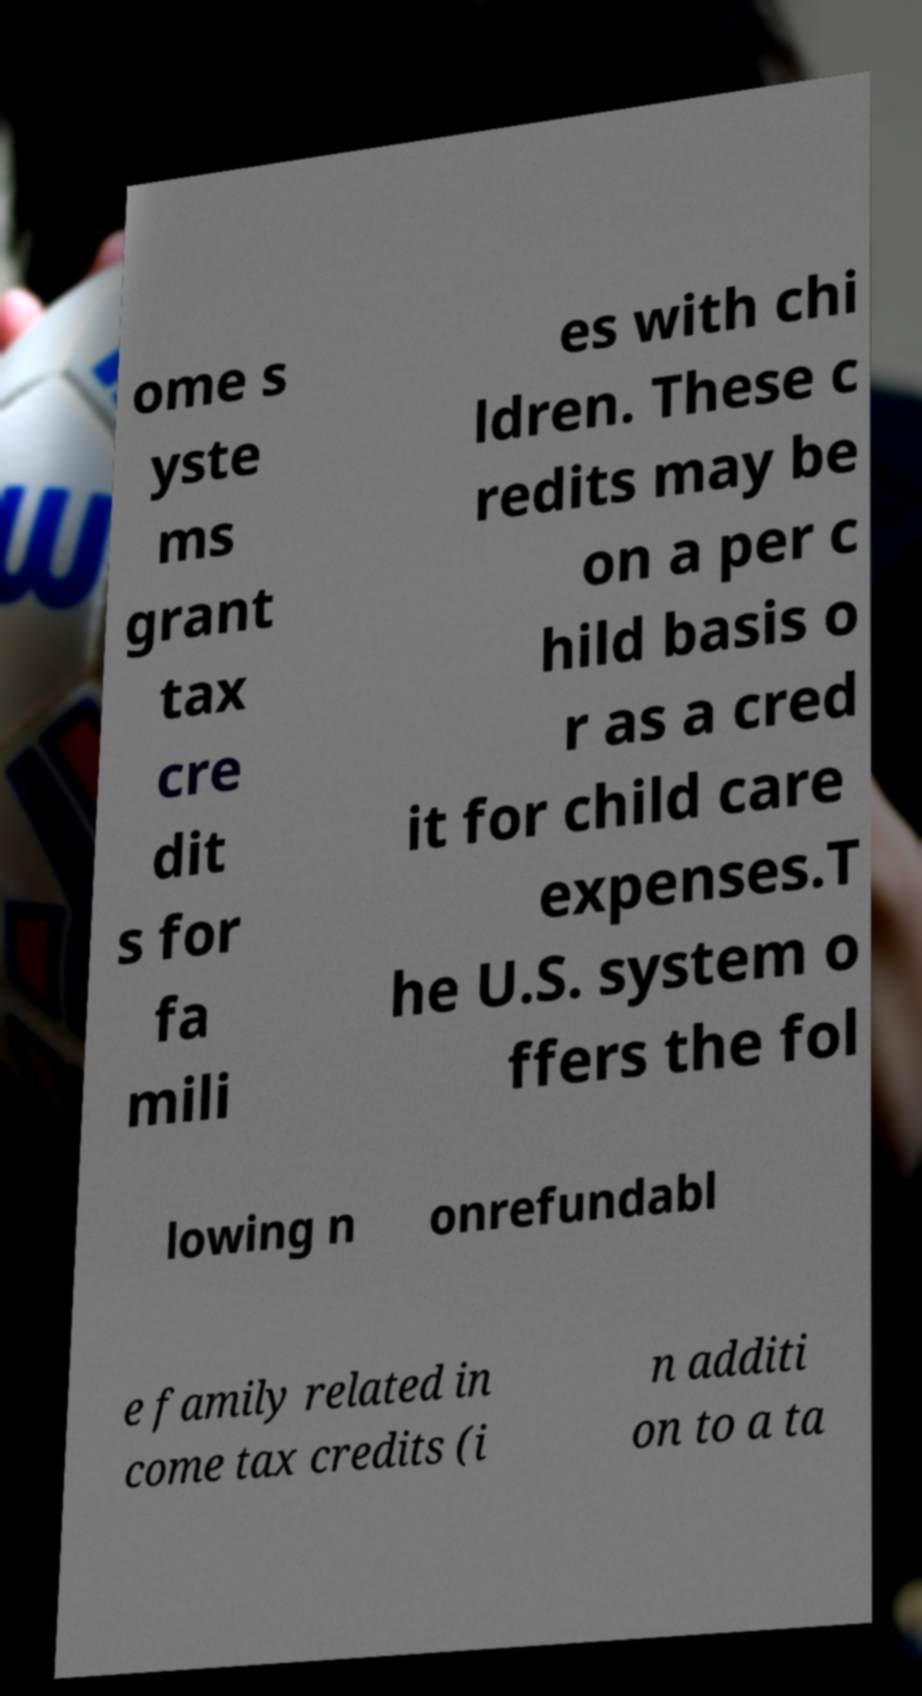Could you extract and type out the text from this image? ome s yste ms grant tax cre dit s for fa mili es with chi ldren. These c redits may be on a per c hild basis o r as a cred it for child care expenses.T he U.S. system o ffers the fol lowing n onrefundabl e family related in come tax credits (i n additi on to a ta 